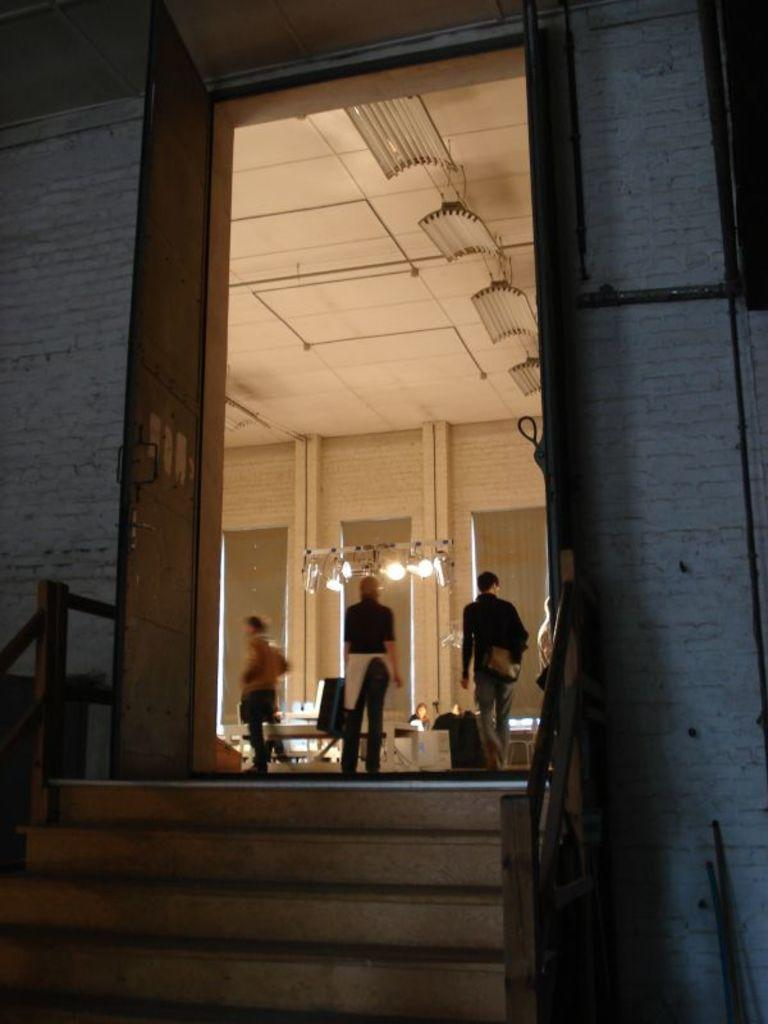What type of structure is present in the image? There is a building in the image. What can be seen on the building? There are stairs with a railing in the image. Are there any people in the image? Yes, there are people standing in the image. What else can be seen in the image? There is a wall and lights visible in the image. What color is the ceiling in the image? The ceiling is cream in color. What type of goat can be seen climbing the stairs in the image? There is no goat present in the image; it features a building with stairs and people. 